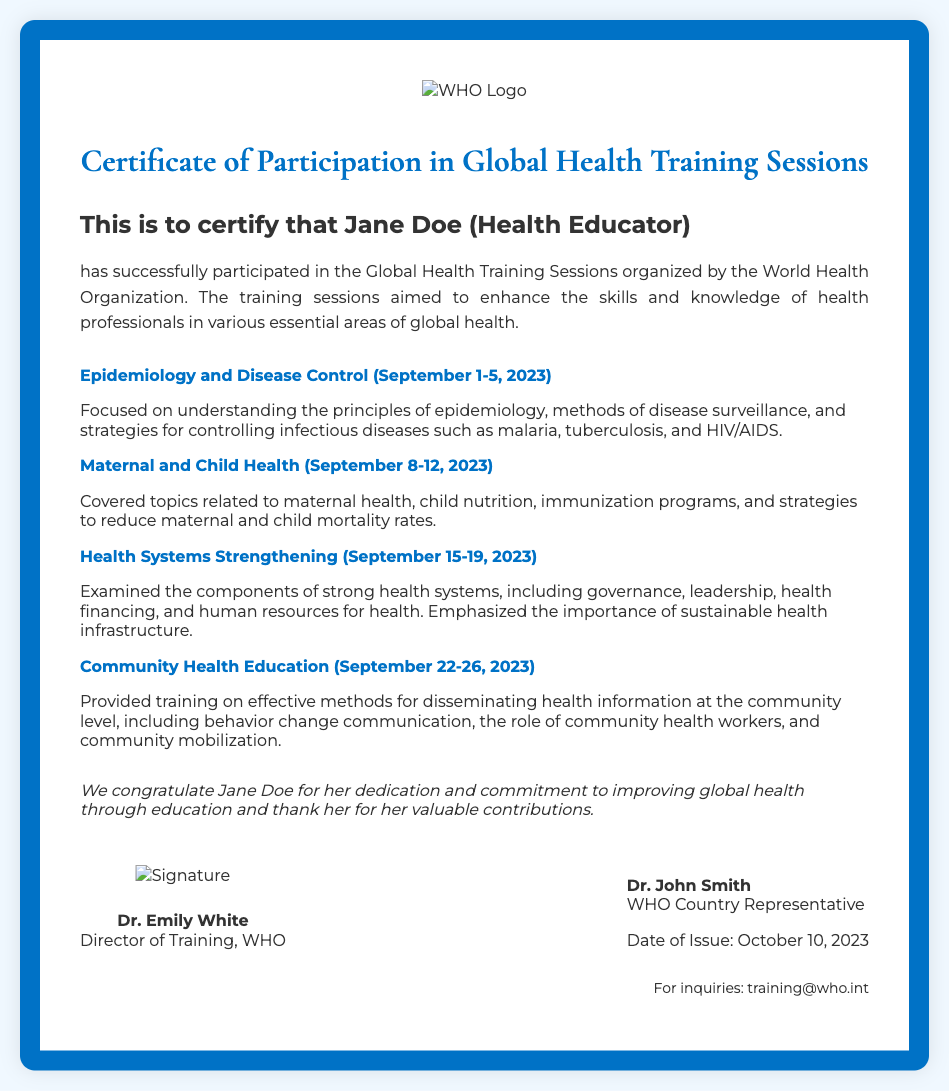What is the name of the participant? The participant's name is specified in the certificate, which presents as "Jane Doe."
Answer: Jane Doe What is the title of the participant? The title given to the participant on the certificate is stated directly after their name.
Answer: Health Educator What organization issued this certificate? The certificate explicitly states the organization that organized the training sessions.
Answer: World Health Organization What is the date of issuance of the certificate? The certificate mentions the date of issue as part of the footer information.
Answer: October 10, 2023 How many training sessions are listed in the certificate? By counting the sessions described in the document, the total number of sessions can be determined.
Answer: Four What is the focus of the first training session? The document provides a brief description of each session’s focus; the first is related to "Epidemiology and Disease Control."
Answer: Epidemiology and Disease Control Who is the Director of Training at the WHO? The signature block provides the name and title of the person who signed the certificate.
Answer: Dr. Emily White What contact information is provided for inquiries? The last part of the document includes contact information for further questions.
Answer: training@who.int What is the main purpose of the training sessions? The document summarizes the goal of the training sessions in a specific statement regarding their aim.
Answer: Enhance skills and knowledge of health professionals 